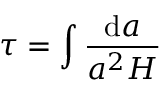Convert formula to latex. <formula><loc_0><loc_0><loc_500><loc_500>\tau = \int \frac { d a } { a ^ { 2 } H }</formula> 